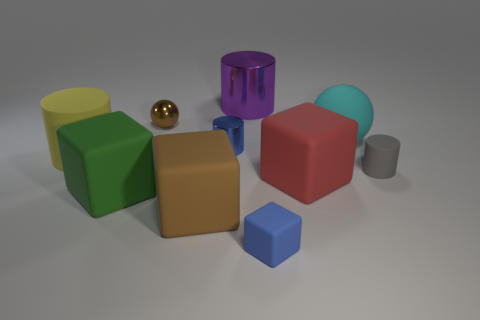Subtract all small matte cylinders. How many cylinders are left? 3 Subtract all yellow balls. Subtract all red blocks. How many balls are left? 2 Subtract all brown cubes. How many cyan balls are left? 1 Subtract all small green rubber objects. Subtract all cubes. How many objects are left? 6 Add 7 big red matte things. How many big red matte things are left? 8 Add 7 large green things. How many large green things exist? 8 Subtract all red cubes. How many cubes are left? 3 Subtract 0 blue spheres. How many objects are left? 10 Subtract all cylinders. How many objects are left? 6 Subtract 1 balls. How many balls are left? 1 